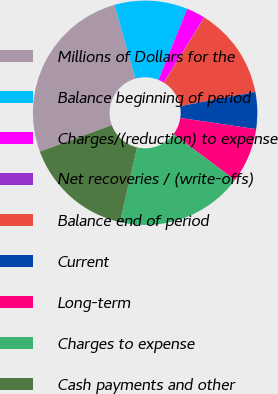Convert chart. <chart><loc_0><loc_0><loc_500><loc_500><pie_chart><fcel>Millions of Dollars for the<fcel>Balance beginning of period<fcel>Charges/(reduction) to expense<fcel>Net recoveries / (write-offs)<fcel>Balance end of period<fcel>Current<fcel>Long-term<fcel>Charges to expense<fcel>Cash payments and other<nl><fcel>26.23%<fcel>10.53%<fcel>2.68%<fcel>0.07%<fcel>13.15%<fcel>5.3%<fcel>7.91%<fcel>18.38%<fcel>15.76%<nl></chart> 